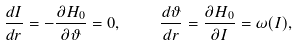Convert formula to latex. <formula><loc_0><loc_0><loc_500><loc_500>\frac { d I } { d r } = - \frac { \partial H _ { 0 } } { \partial \vartheta } = 0 , \quad \frac { d \vartheta } { d r } = \frac { \partial H _ { 0 } } { \partial I } = \omega ( I ) ,</formula> 